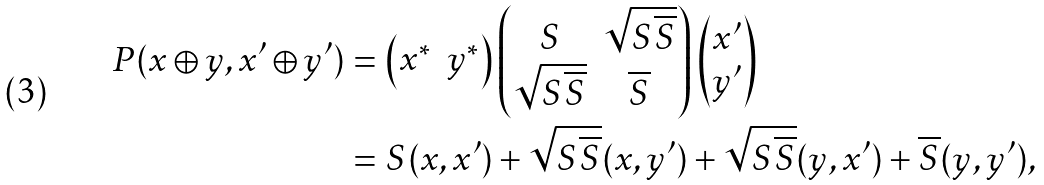<formula> <loc_0><loc_0><loc_500><loc_500>P ( x \oplus y , x ^ { \prime } \oplus y ^ { \prime } ) & = \begin{pmatrix} x ^ { * } & y ^ { * } \end{pmatrix} \begin{pmatrix} S & \sqrt { S { \overline { S } } } \\ \sqrt { S { \overline { S } } } & { \overline { S } } \end{pmatrix} \begin{pmatrix} x ^ { \prime } \\ y ^ { \prime } \end{pmatrix} \\ & = S ( x , x ^ { \prime } ) + \sqrt { S \overline { S } } ( x , y ^ { \prime } ) + \sqrt { S \overline { S } } ( y , x ^ { \prime } ) + \overline { S } ( y , y ^ { \prime } ) ,</formula> 